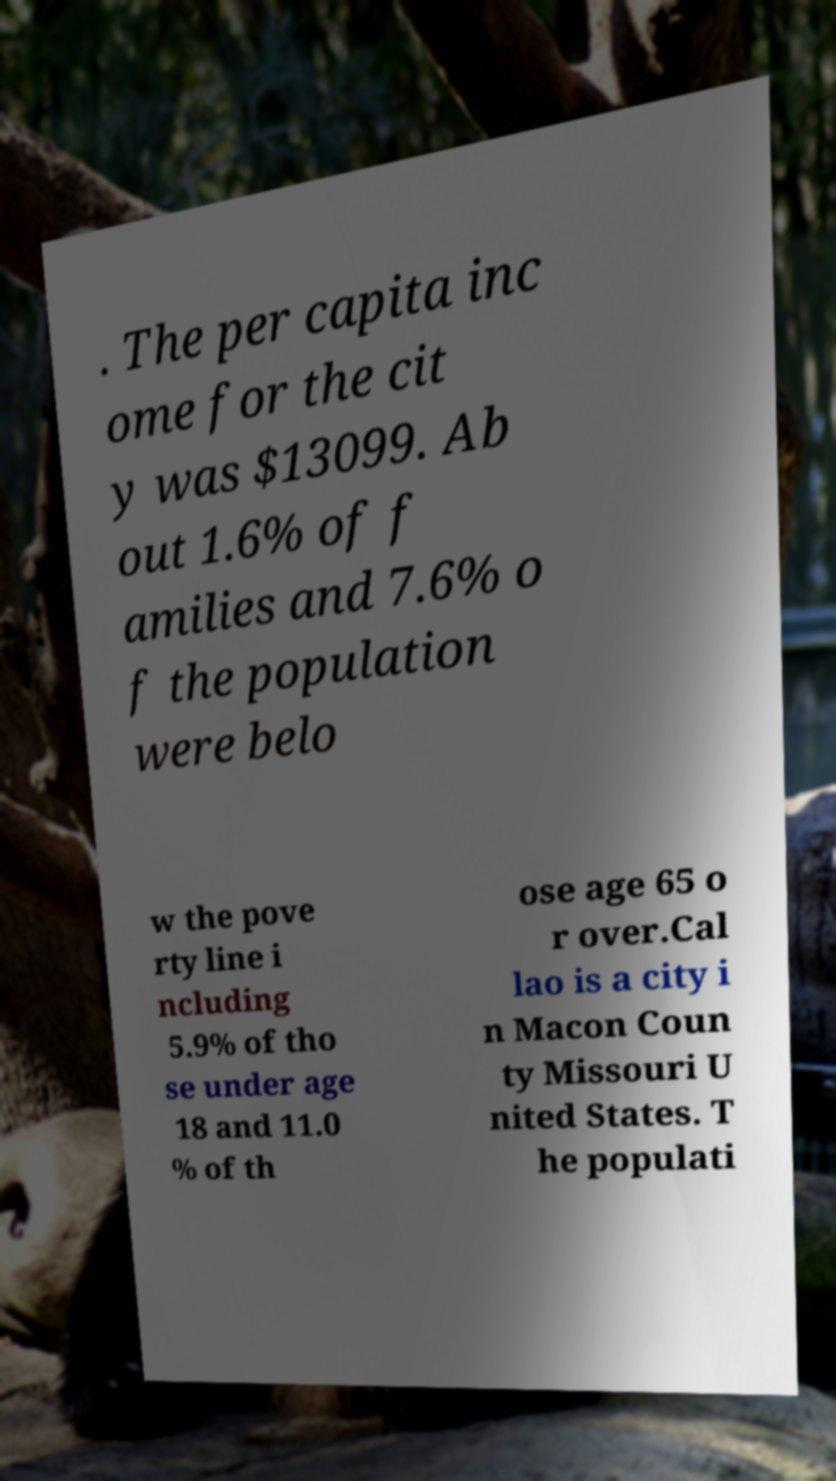For documentation purposes, I need the text within this image transcribed. Could you provide that? . The per capita inc ome for the cit y was $13099. Ab out 1.6% of f amilies and 7.6% o f the population were belo w the pove rty line i ncluding 5.9% of tho se under age 18 and 11.0 % of th ose age 65 o r over.Cal lao is a city i n Macon Coun ty Missouri U nited States. T he populati 